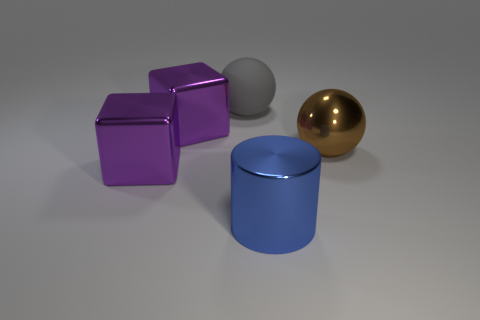There is a big shiny object on the right side of the blue cylinder; is its shape the same as the big matte thing on the left side of the large blue object? Yes, both the large shiny object on the right and the big matte object on the left of the blue cylinder have the same spherical shape, exhibiting symmetry in their form despite the difference in their surface textures. 